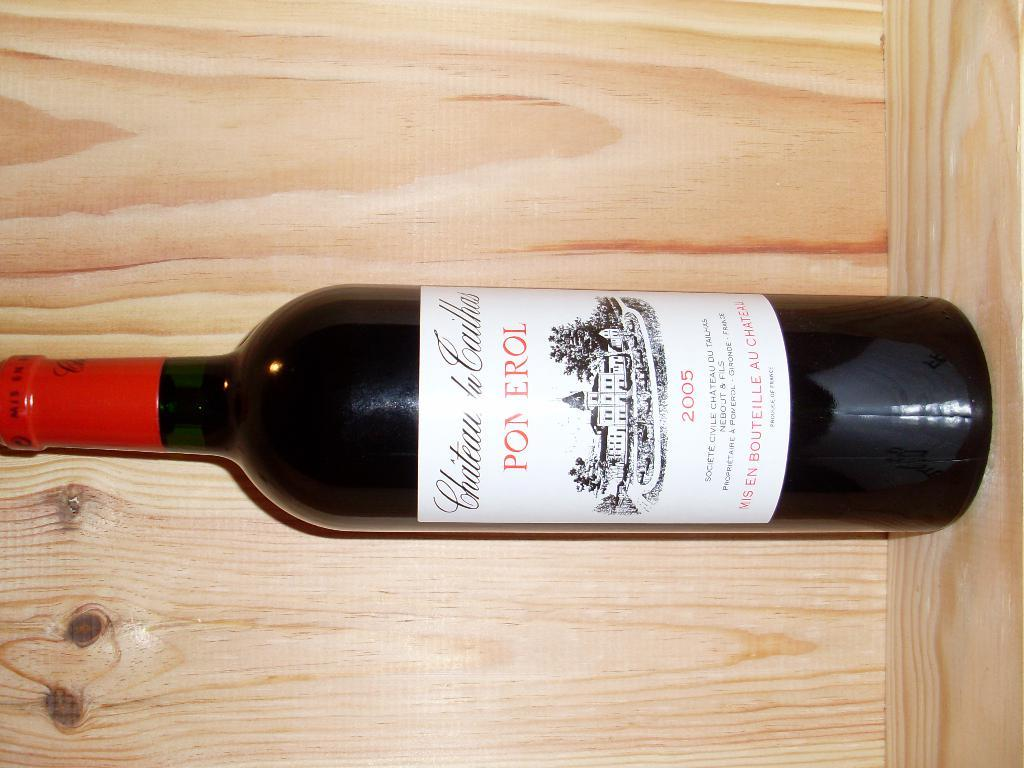What is the main object in the image? There is a wine bottle in the image. Where is the wine bottle located? The wine bottle is on a table. What can be seen in the background of the image? There is a wood wall in the background of the image. What type of leaf is growing on the stem in the image? There is no leaf or stem present in the image; it features a wine bottle on a table with a wood wall in the background. 